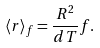<formula> <loc_0><loc_0><loc_500><loc_500>\langle r \rangle _ { f } = \frac { R ^ { 2 } } { d T } f .</formula> 